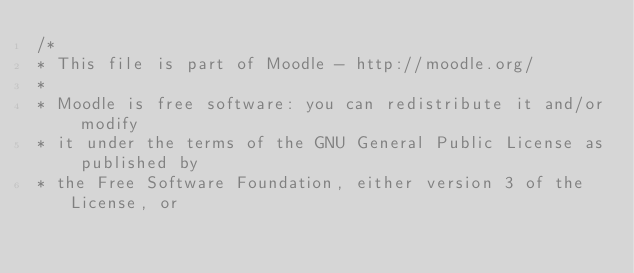<code> <loc_0><loc_0><loc_500><loc_500><_CSS_>/*
* This file is part of Moodle - http://moodle.org/
*
* Moodle is free software: you can redistribute it and/or modify
* it under the terms of the GNU General Public License as published by
* the Free Software Foundation, either version 3 of the License, or</code> 